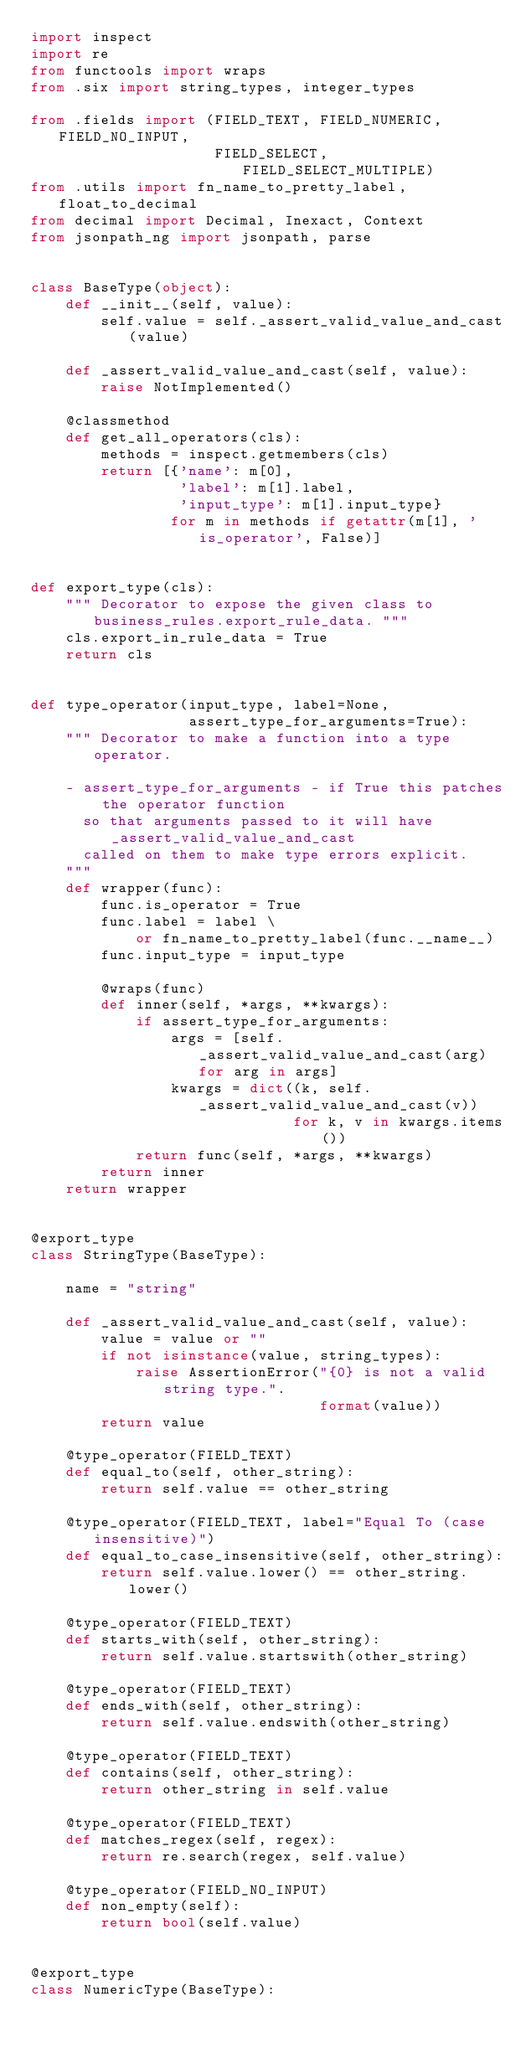Convert code to text. <code><loc_0><loc_0><loc_500><loc_500><_Python_>import inspect
import re
from functools import wraps
from .six import string_types, integer_types

from .fields import (FIELD_TEXT, FIELD_NUMERIC, FIELD_NO_INPUT,
                     FIELD_SELECT, FIELD_SELECT_MULTIPLE)
from .utils import fn_name_to_pretty_label, float_to_decimal
from decimal import Decimal, Inexact, Context
from jsonpath_ng import jsonpath, parse


class BaseType(object):
    def __init__(self, value):
        self.value = self._assert_valid_value_and_cast(value)

    def _assert_valid_value_and_cast(self, value):
        raise NotImplemented()

    @classmethod
    def get_all_operators(cls):
        methods = inspect.getmembers(cls)
        return [{'name': m[0],
                 'label': m[1].label,
                 'input_type': m[1].input_type}
                for m in methods if getattr(m[1], 'is_operator', False)]


def export_type(cls):
    """ Decorator to expose the given class to business_rules.export_rule_data. """
    cls.export_in_rule_data = True
    return cls


def type_operator(input_type, label=None,
                  assert_type_for_arguments=True):
    """ Decorator to make a function into a type operator.

    - assert_type_for_arguments - if True this patches the operator function
      so that arguments passed to it will have _assert_valid_value_and_cast
      called on them to make type errors explicit.
    """
    def wrapper(func):
        func.is_operator = True
        func.label = label \
            or fn_name_to_pretty_label(func.__name__)
        func.input_type = input_type

        @wraps(func)
        def inner(self, *args, **kwargs):
            if assert_type_for_arguments:
                args = [self._assert_valid_value_and_cast(arg) for arg in args]
                kwargs = dict((k, self._assert_valid_value_and_cast(v))
                              for k, v in kwargs.items())
            return func(self, *args, **kwargs)
        return inner
    return wrapper


@export_type
class StringType(BaseType):

    name = "string"

    def _assert_valid_value_and_cast(self, value):
        value = value or ""
        if not isinstance(value, string_types):
            raise AssertionError("{0} is not a valid string type.".
                                 format(value))
        return value

    @type_operator(FIELD_TEXT)
    def equal_to(self, other_string):
        return self.value == other_string

    @type_operator(FIELD_TEXT, label="Equal To (case insensitive)")
    def equal_to_case_insensitive(self, other_string):
        return self.value.lower() == other_string.lower()

    @type_operator(FIELD_TEXT)
    def starts_with(self, other_string):
        return self.value.startswith(other_string)

    @type_operator(FIELD_TEXT)
    def ends_with(self, other_string):
        return self.value.endswith(other_string)

    @type_operator(FIELD_TEXT)
    def contains(self, other_string):
        return other_string in self.value

    @type_operator(FIELD_TEXT)
    def matches_regex(self, regex):
        return re.search(regex, self.value)

    @type_operator(FIELD_NO_INPUT)
    def non_empty(self):
        return bool(self.value)


@export_type
class NumericType(BaseType):</code> 